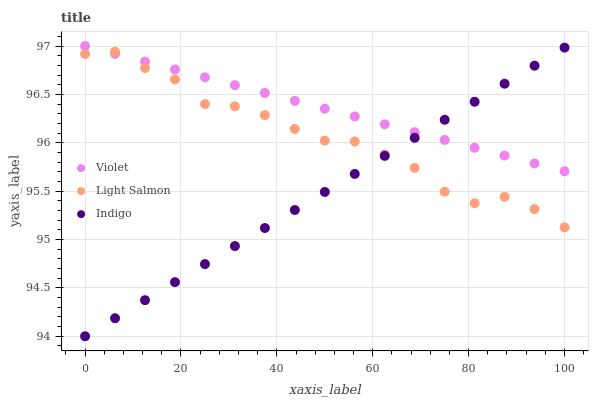Does Indigo have the minimum area under the curve?
Answer yes or no. Yes. Does Violet have the maximum area under the curve?
Answer yes or no. Yes. Does Violet have the minimum area under the curve?
Answer yes or no. No. Does Indigo have the maximum area under the curve?
Answer yes or no. No. Is Indigo the smoothest?
Answer yes or no. Yes. Is Light Salmon the roughest?
Answer yes or no. Yes. Is Violet the smoothest?
Answer yes or no. No. Is Violet the roughest?
Answer yes or no. No. Does Indigo have the lowest value?
Answer yes or no. Yes. Does Violet have the lowest value?
Answer yes or no. No. Does Violet have the highest value?
Answer yes or no. Yes. Does Indigo have the highest value?
Answer yes or no. No. Does Indigo intersect Light Salmon?
Answer yes or no. Yes. Is Indigo less than Light Salmon?
Answer yes or no. No. Is Indigo greater than Light Salmon?
Answer yes or no. No. 